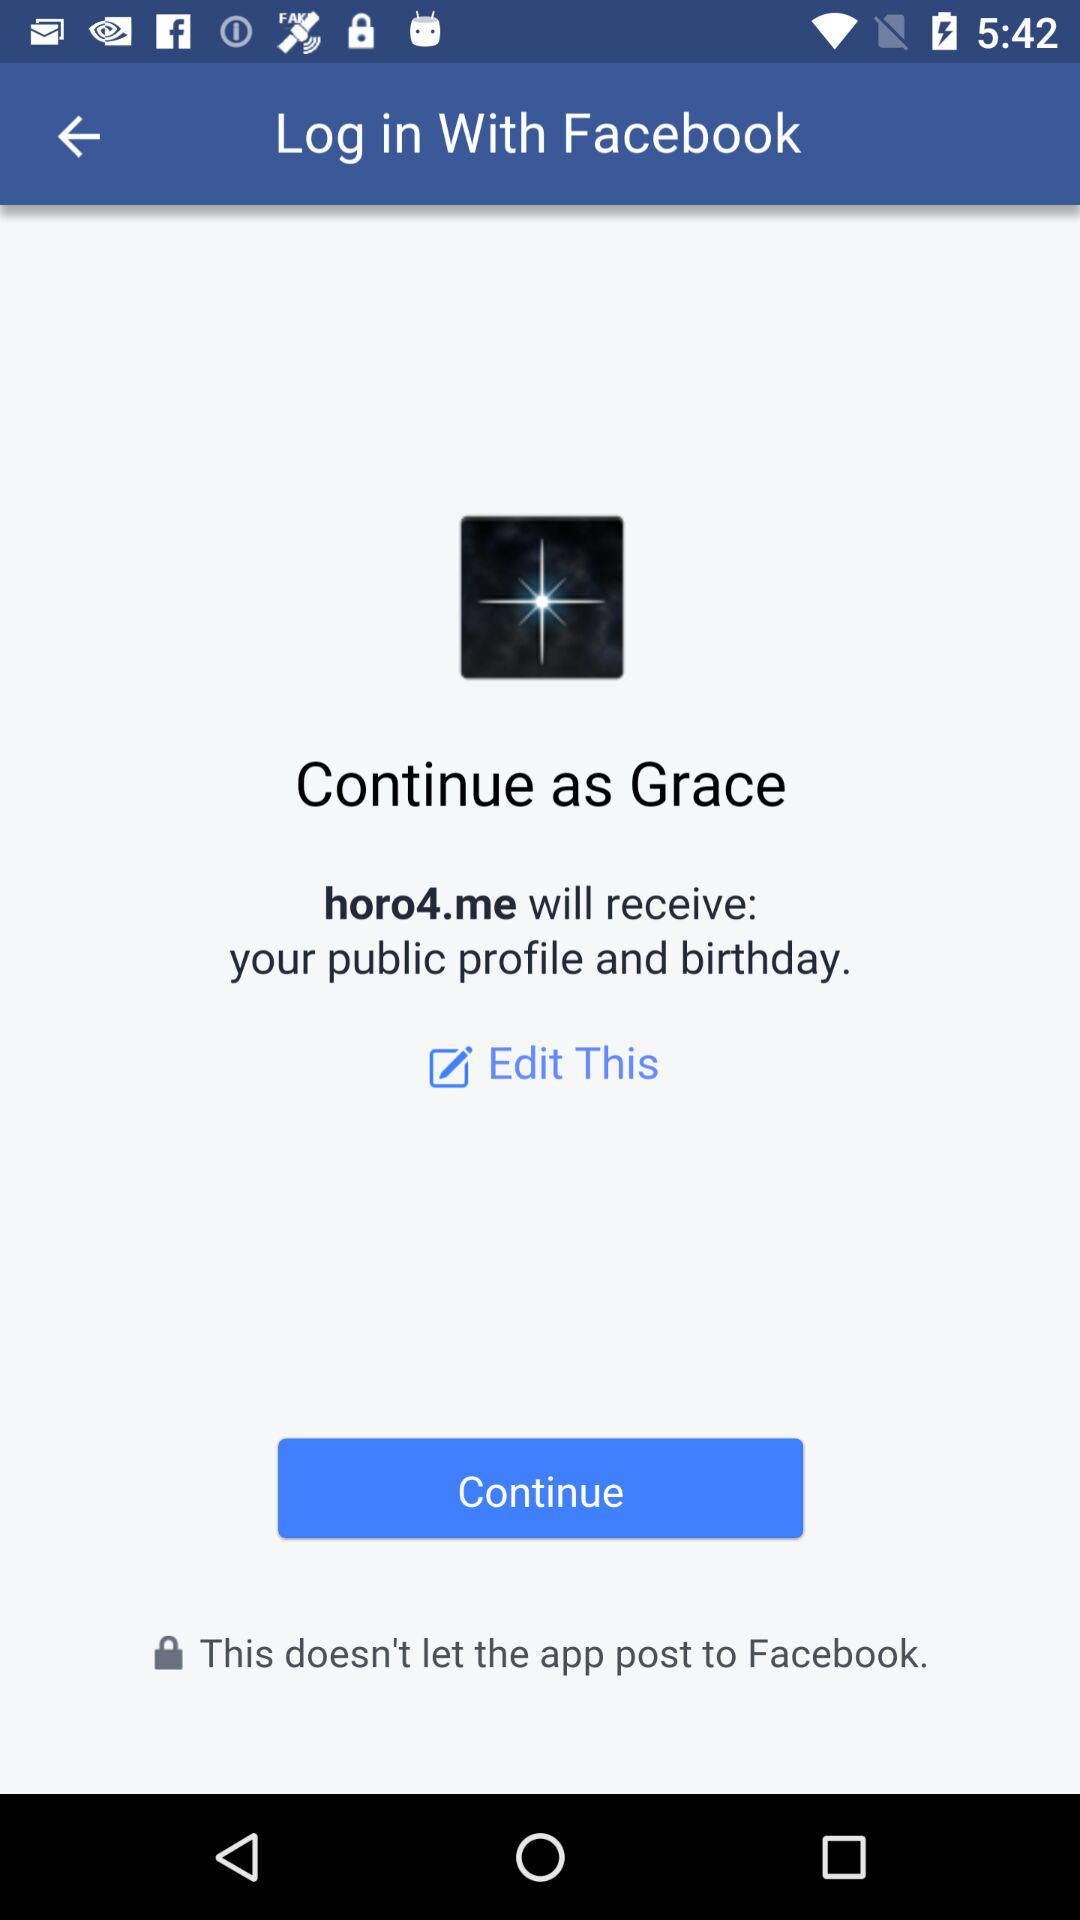What application will receive a public profile and birthday? The application is "horo4.me". 